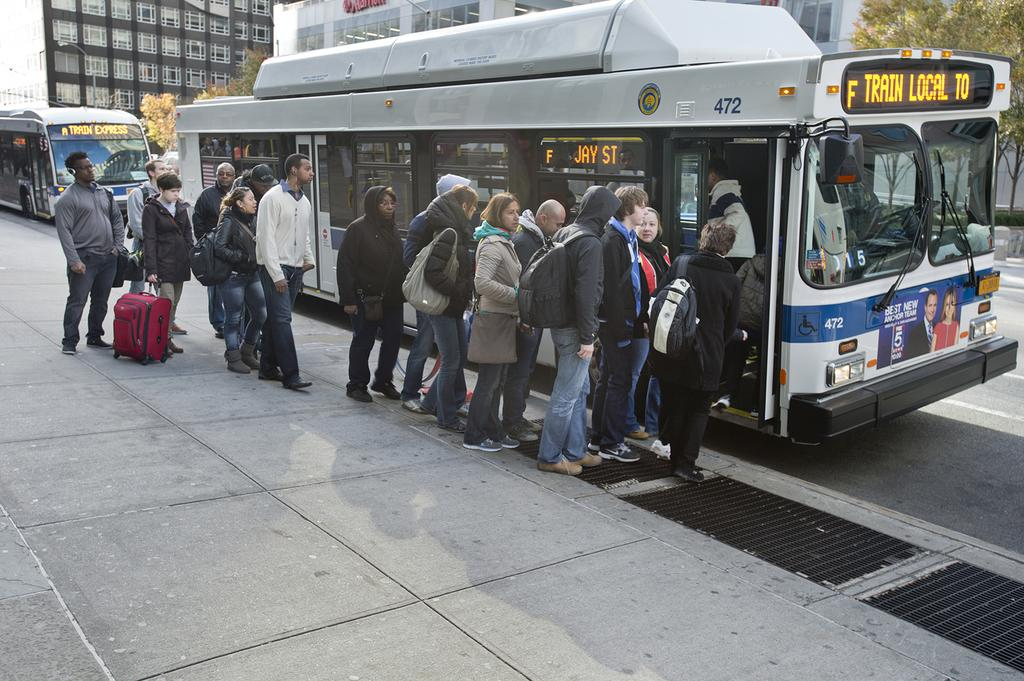What is happening in the image? There is a group of people standing in the image. What else can be seen in the image besides the people? There are vehicles in the image. What can be seen in the background of the image? There are trees and buildings in the background of the image. What is the color of the trees in the image? The trees are green in color. How many girls are present in the image? The provided facts do not mention any girls in the image, so we cannot determine the number of girls present. 